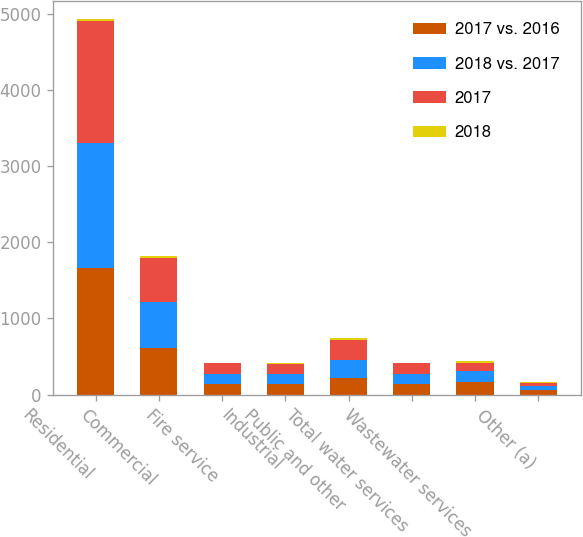<chart> <loc_0><loc_0><loc_500><loc_500><stacked_bar_chart><ecel><fcel>Residential<fcel>Commercial<fcel>Fire service<fcel>Industrial<fcel>Public and other<fcel>Total water services<fcel>Wastewater services<fcel>Other (a)<nl><fcel>2017 vs. 2016<fcel>1663<fcel>616<fcel>137<fcel>136<fcel>216<fcel>136<fcel>161<fcel>55<nl><fcel>2018 vs. 2017<fcel>1644<fcel>601<fcel>139<fcel>137<fcel>244<fcel>136<fcel>142<fcel>51<nl><fcel>2017<fcel>1601<fcel>582<fcel>134<fcel>134<fcel>259<fcel>136<fcel>112<fcel>49<nl><fcel>2018<fcel>19<fcel>15<fcel>2<fcel>1<fcel>28<fcel>3<fcel>19<fcel>4<nl></chart> 